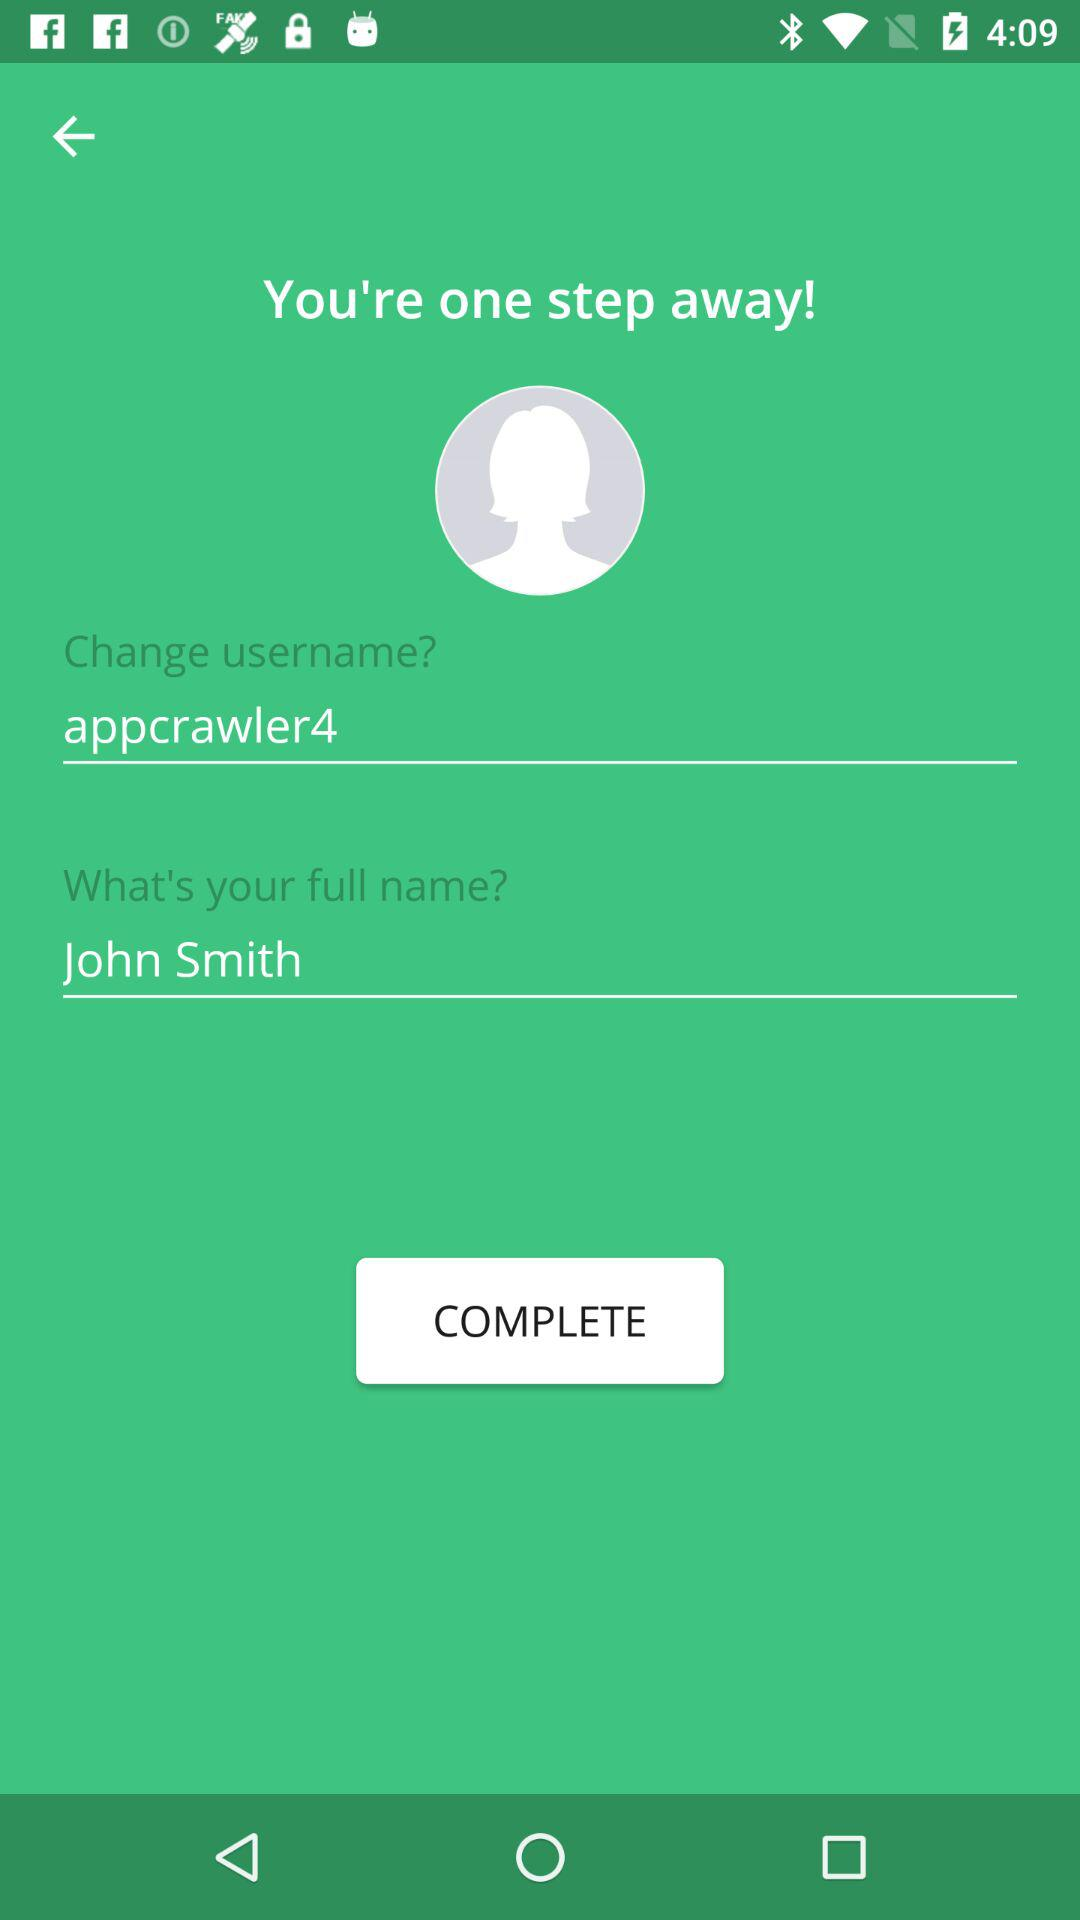What is the full name? The full name is John Smith. 